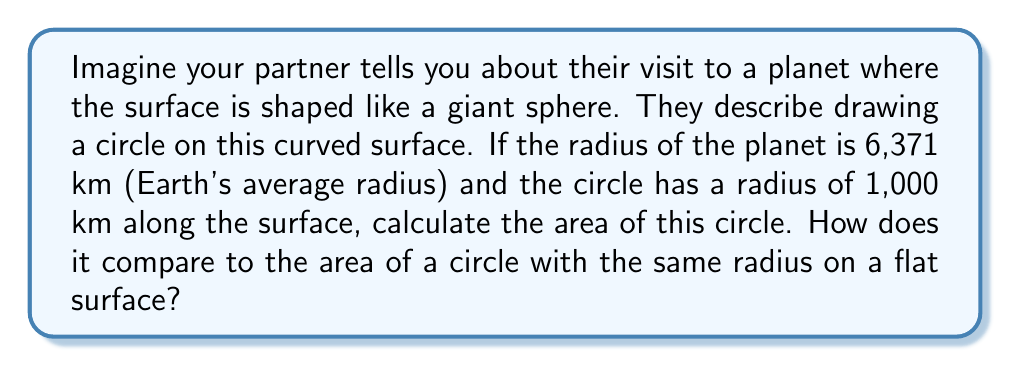Solve this math problem. Let's approach this step-by-step:

1) On a spherical surface (elliptic geometry), the area of a circle is given by the formula:

   $$A = 2\pi R^2 \left(1 - \cos\frac{r}{R}\right)$$

   Where $R$ is the radius of the sphere and $r$ is the radius of the circle on the surface.

2) We're given:
   $R = 6,371$ km (radius of the planet)
   $r = 1,000$ km (radius of the circle on the surface)

3) Let's substitute these values into our formula:

   $$A = 2\pi (6,371)^2 \left(1 - \cos\frac{1,000}{6,371}\right)$$

4) Now, let's calculate:
   
   $$A \approx 2\pi (40,589,641) (1 - 0.9876)$$
   $$A \approx 255,176,331 \times 0.0124$$
   $$A \approx 3,164,187 \text{ km}^2$$

5) For comparison, let's calculate the area of a circle with the same radius on a flat surface using the familiar Euclidean formula $A = \pi r^2$:

   $$A = \pi (1,000)^2 = 3,141,593 \text{ km}^2$$

6) The difference is:

   $$3,164,187 - 3,141,593 = 22,594 \text{ km}^2$$

   The area on the spherical surface is larger by about 22,594 km².

7) This difference is due to the curvature of the spherical surface. As the size of the circle increases relative to the size of the sphere, this difference becomes more pronounced.
Answer: $3,164,187 \text{ km}^2$; $22,594 \text{ km}^2$ larger than on a flat surface 